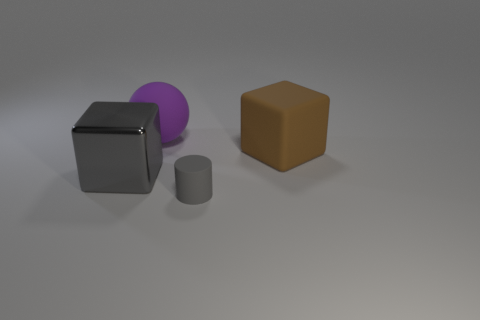Add 3 big brown matte blocks. How many objects exist? 7 Subtract all cylinders. How many objects are left? 3 Add 2 small objects. How many small objects exist? 3 Subtract 0 green blocks. How many objects are left? 4 Subtract all red shiny cylinders. Subtract all small gray rubber objects. How many objects are left? 3 Add 3 large purple matte objects. How many large purple matte objects are left? 4 